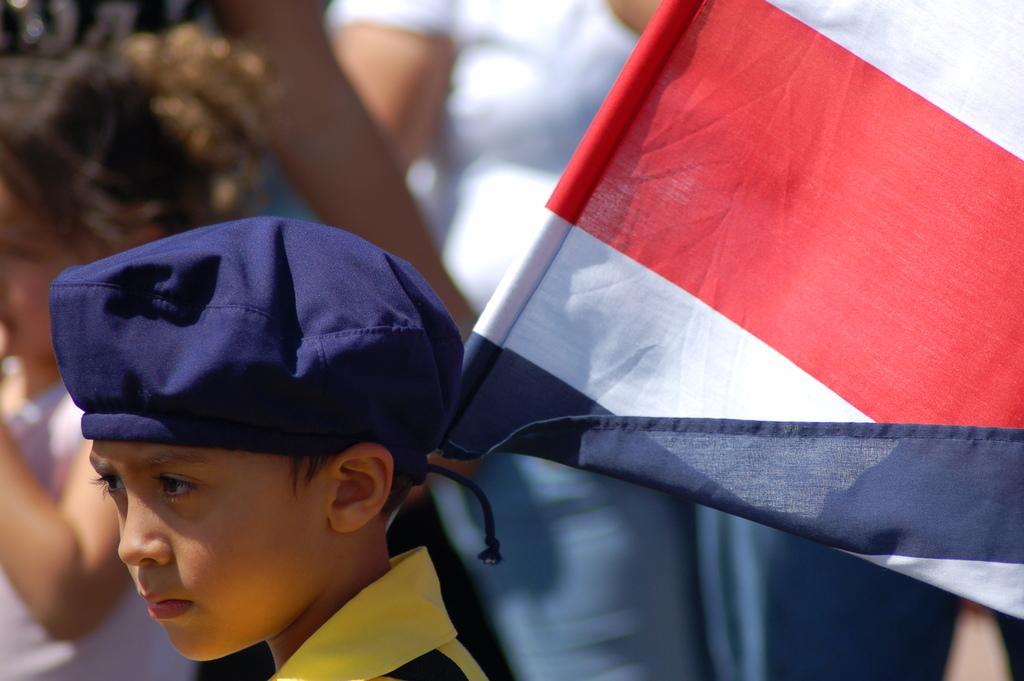Describe this image in one or two sentences. At the bottom there is a boy wearing a t-shirt, a cap on the head and holding a flag. In the background, I can see some people. 